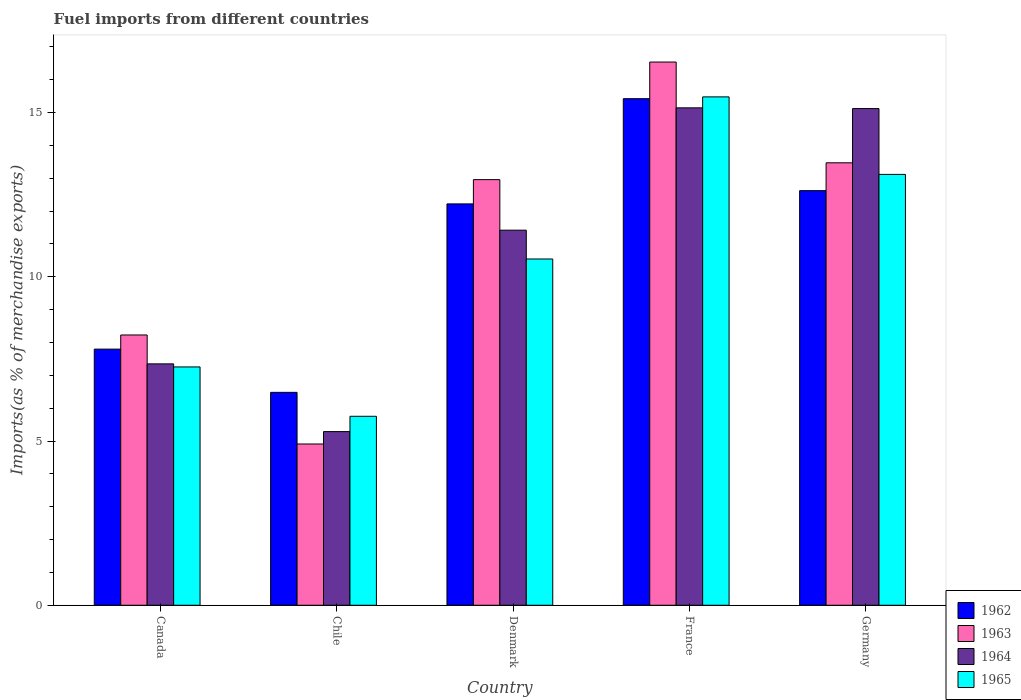Are the number of bars per tick equal to the number of legend labels?
Give a very brief answer. Yes. Are the number of bars on each tick of the X-axis equal?
Provide a succinct answer. Yes. In how many cases, is the number of bars for a given country not equal to the number of legend labels?
Provide a short and direct response. 0. What is the percentage of imports to different countries in 1963 in Canada?
Give a very brief answer. 8.23. Across all countries, what is the maximum percentage of imports to different countries in 1962?
Ensure brevity in your answer.  15.42. Across all countries, what is the minimum percentage of imports to different countries in 1963?
Offer a terse response. 4.91. What is the total percentage of imports to different countries in 1965 in the graph?
Offer a very short reply. 52.14. What is the difference between the percentage of imports to different countries in 1965 in Chile and that in Germany?
Your answer should be very brief. -7.36. What is the difference between the percentage of imports to different countries in 1963 in France and the percentage of imports to different countries in 1965 in Germany?
Your answer should be compact. 3.42. What is the average percentage of imports to different countries in 1965 per country?
Offer a very short reply. 10.43. What is the difference between the percentage of imports to different countries of/in 1963 and percentage of imports to different countries of/in 1965 in Canada?
Keep it short and to the point. 0.97. In how many countries, is the percentage of imports to different countries in 1962 greater than 7 %?
Your answer should be very brief. 4. What is the ratio of the percentage of imports to different countries in 1964 in Chile to that in Germany?
Ensure brevity in your answer.  0.35. Is the difference between the percentage of imports to different countries in 1963 in Chile and Denmark greater than the difference between the percentage of imports to different countries in 1965 in Chile and Denmark?
Make the answer very short. No. What is the difference between the highest and the second highest percentage of imports to different countries in 1963?
Make the answer very short. 3.58. What is the difference between the highest and the lowest percentage of imports to different countries in 1965?
Offer a terse response. 9.72. In how many countries, is the percentage of imports to different countries in 1964 greater than the average percentage of imports to different countries in 1964 taken over all countries?
Keep it short and to the point. 3. What does the 4th bar from the left in France represents?
Your response must be concise. 1965. What does the 4th bar from the right in France represents?
Your answer should be compact. 1962. How many bars are there?
Your answer should be compact. 20. Are all the bars in the graph horizontal?
Ensure brevity in your answer.  No. What is the difference between two consecutive major ticks on the Y-axis?
Make the answer very short. 5. Are the values on the major ticks of Y-axis written in scientific E-notation?
Provide a succinct answer. No. Does the graph contain any zero values?
Provide a short and direct response. No. Where does the legend appear in the graph?
Ensure brevity in your answer.  Bottom right. How many legend labels are there?
Your response must be concise. 4. What is the title of the graph?
Make the answer very short. Fuel imports from different countries. What is the label or title of the Y-axis?
Provide a succinct answer. Imports(as % of merchandise exports). What is the Imports(as % of merchandise exports) of 1962 in Canada?
Your response must be concise. 7.8. What is the Imports(as % of merchandise exports) of 1963 in Canada?
Provide a succinct answer. 8.23. What is the Imports(as % of merchandise exports) of 1964 in Canada?
Your response must be concise. 7.35. What is the Imports(as % of merchandise exports) of 1965 in Canada?
Ensure brevity in your answer.  7.26. What is the Imports(as % of merchandise exports) in 1962 in Chile?
Provide a short and direct response. 6.48. What is the Imports(as % of merchandise exports) in 1963 in Chile?
Give a very brief answer. 4.91. What is the Imports(as % of merchandise exports) of 1964 in Chile?
Your response must be concise. 5.29. What is the Imports(as % of merchandise exports) in 1965 in Chile?
Provide a short and direct response. 5.75. What is the Imports(as % of merchandise exports) of 1962 in Denmark?
Your answer should be very brief. 12.22. What is the Imports(as % of merchandise exports) in 1963 in Denmark?
Your response must be concise. 12.96. What is the Imports(as % of merchandise exports) in 1964 in Denmark?
Your answer should be compact. 11.42. What is the Imports(as % of merchandise exports) in 1965 in Denmark?
Offer a very short reply. 10.54. What is the Imports(as % of merchandise exports) in 1962 in France?
Offer a very short reply. 15.42. What is the Imports(as % of merchandise exports) of 1963 in France?
Offer a very short reply. 16.54. What is the Imports(as % of merchandise exports) of 1964 in France?
Give a very brief answer. 15.14. What is the Imports(as % of merchandise exports) in 1965 in France?
Your answer should be very brief. 15.48. What is the Imports(as % of merchandise exports) in 1962 in Germany?
Give a very brief answer. 12.62. What is the Imports(as % of merchandise exports) in 1963 in Germany?
Ensure brevity in your answer.  13.47. What is the Imports(as % of merchandise exports) of 1964 in Germany?
Your response must be concise. 15.12. What is the Imports(as % of merchandise exports) of 1965 in Germany?
Your response must be concise. 13.12. Across all countries, what is the maximum Imports(as % of merchandise exports) of 1962?
Your answer should be compact. 15.42. Across all countries, what is the maximum Imports(as % of merchandise exports) of 1963?
Make the answer very short. 16.54. Across all countries, what is the maximum Imports(as % of merchandise exports) of 1964?
Keep it short and to the point. 15.14. Across all countries, what is the maximum Imports(as % of merchandise exports) of 1965?
Make the answer very short. 15.48. Across all countries, what is the minimum Imports(as % of merchandise exports) of 1962?
Provide a succinct answer. 6.48. Across all countries, what is the minimum Imports(as % of merchandise exports) in 1963?
Offer a terse response. 4.91. Across all countries, what is the minimum Imports(as % of merchandise exports) of 1964?
Provide a succinct answer. 5.29. Across all countries, what is the minimum Imports(as % of merchandise exports) in 1965?
Keep it short and to the point. 5.75. What is the total Imports(as % of merchandise exports) in 1962 in the graph?
Your answer should be compact. 54.54. What is the total Imports(as % of merchandise exports) of 1963 in the graph?
Your answer should be compact. 56.1. What is the total Imports(as % of merchandise exports) in 1964 in the graph?
Provide a short and direct response. 54.32. What is the total Imports(as % of merchandise exports) of 1965 in the graph?
Ensure brevity in your answer.  52.14. What is the difference between the Imports(as % of merchandise exports) in 1962 in Canada and that in Chile?
Offer a terse response. 1.32. What is the difference between the Imports(as % of merchandise exports) in 1963 in Canada and that in Chile?
Make the answer very short. 3.32. What is the difference between the Imports(as % of merchandise exports) in 1964 in Canada and that in Chile?
Your answer should be very brief. 2.06. What is the difference between the Imports(as % of merchandise exports) in 1965 in Canada and that in Chile?
Make the answer very short. 1.5. What is the difference between the Imports(as % of merchandise exports) in 1962 in Canada and that in Denmark?
Your answer should be compact. -4.42. What is the difference between the Imports(as % of merchandise exports) in 1963 in Canada and that in Denmark?
Your response must be concise. -4.73. What is the difference between the Imports(as % of merchandise exports) in 1964 in Canada and that in Denmark?
Your answer should be very brief. -4.07. What is the difference between the Imports(as % of merchandise exports) in 1965 in Canada and that in Denmark?
Provide a short and direct response. -3.29. What is the difference between the Imports(as % of merchandise exports) of 1962 in Canada and that in France?
Offer a terse response. -7.62. What is the difference between the Imports(as % of merchandise exports) in 1963 in Canada and that in France?
Keep it short and to the point. -8.31. What is the difference between the Imports(as % of merchandise exports) in 1964 in Canada and that in France?
Your answer should be compact. -7.79. What is the difference between the Imports(as % of merchandise exports) in 1965 in Canada and that in France?
Your answer should be compact. -8.22. What is the difference between the Imports(as % of merchandise exports) of 1962 in Canada and that in Germany?
Your answer should be compact. -4.82. What is the difference between the Imports(as % of merchandise exports) in 1963 in Canada and that in Germany?
Your answer should be very brief. -5.24. What is the difference between the Imports(as % of merchandise exports) of 1964 in Canada and that in Germany?
Offer a terse response. -7.77. What is the difference between the Imports(as % of merchandise exports) in 1965 in Canada and that in Germany?
Your response must be concise. -5.86. What is the difference between the Imports(as % of merchandise exports) of 1962 in Chile and that in Denmark?
Provide a short and direct response. -5.74. What is the difference between the Imports(as % of merchandise exports) in 1963 in Chile and that in Denmark?
Make the answer very short. -8.05. What is the difference between the Imports(as % of merchandise exports) of 1964 in Chile and that in Denmark?
Your answer should be very brief. -6.13. What is the difference between the Imports(as % of merchandise exports) in 1965 in Chile and that in Denmark?
Make the answer very short. -4.79. What is the difference between the Imports(as % of merchandise exports) in 1962 in Chile and that in France?
Keep it short and to the point. -8.94. What is the difference between the Imports(as % of merchandise exports) of 1963 in Chile and that in France?
Provide a short and direct response. -11.63. What is the difference between the Imports(as % of merchandise exports) of 1964 in Chile and that in France?
Offer a terse response. -9.86. What is the difference between the Imports(as % of merchandise exports) of 1965 in Chile and that in France?
Provide a succinct answer. -9.72. What is the difference between the Imports(as % of merchandise exports) of 1962 in Chile and that in Germany?
Offer a very short reply. -6.14. What is the difference between the Imports(as % of merchandise exports) in 1963 in Chile and that in Germany?
Make the answer very short. -8.56. What is the difference between the Imports(as % of merchandise exports) in 1964 in Chile and that in Germany?
Ensure brevity in your answer.  -9.83. What is the difference between the Imports(as % of merchandise exports) in 1965 in Chile and that in Germany?
Give a very brief answer. -7.36. What is the difference between the Imports(as % of merchandise exports) in 1962 in Denmark and that in France?
Provide a succinct answer. -3.2. What is the difference between the Imports(as % of merchandise exports) in 1963 in Denmark and that in France?
Your response must be concise. -3.58. What is the difference between the Imports(as % of merchandise exports) in 1964 in Denmark and that in France?
Provide a succinct answer. -3.72. What is the difference between the Imports(as % of merchandise exports) in 1965 in Denmark and that in France?
Your response must be concise. -4.94. What is the difference between the Imports(as % of merchandise exports) of 1962 in Denmark and that in Germany?
Make the answer very short. -0.4. What is the difference between the Imports(as % of merchandise exports) in 1963 in Denmark and that in Germany?
Your response must be concise. -0.51. What is the difference between the Imports(as % of merchandise exports) in 1964 in Denmark and that in Germany?
Keep it short and to the point. -3.7. What is the difference between the Imports(as % of merchandise exports) of 1965 in Denmark and that in Germany?
Provide a short and direct response. -2.58. What is the difference between the Imports(as % of merchandise exports) of 1962 in France and that in Germany?
Your response must be concise. 2.8. What is the difference between the Imports(as % of merchandise exports) in 1963 in France and that in Germany?
Make the answer very short. 3.07. What is the difference between the Imports(as % of merchandise exports) in 1964 in France and that in Germany?
Keep it short and to the point. 0.02. What is the difference between the Imports(as % of merchandise exports) of 1965 in France and that in Germany?
Provide a succinct answer. 2.36. What is the difference between the Imports(as % of merchandise exports) of 1962 in Canada and the Imports(as % of merchandise exports) of 1963 in Chile?
Ensure brevity in your answer.  2.89. What is the difference between the Imports(as % of merchandise exports) of 1962 in Canada and the Imports(as % of merchandise exports) of 1964 in Chile?
Give a very brief answer. 2.51. What is the difference between the Imports(as % of merchandise exports) in 1962 in Canada and the Imports(as % of merchandise exports) in 1965 in Chile?
Offer a terse response. 2.04. What is the difference between the Imports(as % of merchandise exports) in 1963 in Canada and the Imports(as % of merchandise exports) in 1964 in Chile?
Ensure brevity in your answer.  2.94. What is the difference between the Imports(as % of merchandise exports) in 1963 in Canada and the Imports(as % of merchandise exports) in 1965 in Chile?
Ensure brevity in your answer.  2.48. What is the difference between the Imports(as % of merchandise exports) of 1964 in Canada and the Imports(as % of merchandise exports) of 1965 in Chile?
Your answer should be compact. 1.6. What is the difference between the Imports(as % of merchandise exports) of 1962 in Canada and the Imports(as % of merchandise exports) of 1963 in Denmark?
Offer a very short reply. -5.16. What is the difference between the Imports(as % of merchandise exports) of 1962 in Canada and the Imports(as % of merchandise exports) of 1964 in Denmark?
Your response must be concise. -3.62. What is the difference between the Imports(as % of merchandise exports) of 1962 in Canada and the Imports(as % of merchandise exports) of 1965 in Denmark?
Give a very brief answer. -2.74. What is the difference between the Imports(as % of merchandise exports) of 1963 in Canada and the Imports(as % of merchandise exports) of 1964 in Denmark?
Offer a terse response. -3.19. What is the difference between the Imports(as % of merchandise exports) of 1963 in Canada and the Imports(as % of merchandise exports) of 1965 in Denmark?
Make the answer very short. -2.31. What is the difference between the Imports(as % of merchandise exports) in 1964 in Canada and the Imports(as % of merchandise exports) in 1965 in Denmark?
Make the answer very short. -3.19. What is the difference between the Imports(as % of merchandise exports) of 1962 in Canada and the Imports(as % of merchandise exports) of 1963 in France?
Make the answer very short. -8.74. What is the difference between the Imports(as % of merchandise exports) in 1962 in Canada and the Imports(as % of merchandise exports) in 1964 in France?
Make the answer very short. -7.35. What is the difference between the Imports(as % of merchandise exports) of 1962 in Canada and the Imports(as % of merchandise exports) of 1965 in France?
Your answer should be compact. -7.68. What is the difference between the Imports(as % of merchandise exports) of 1963 in Canada and the Imports(as % of merchandise exports) of 1964 in France?
Ensure brevity in your answer.  -6.91. What is the difference between the Imports(as % of merchandise exports) in 1963 in Canada and the Imports(as % of merchandise exports) in 1965 in France?
Provide a succinct answer. -7.25. What is the difference between the Imports(as % of merchandise exports) of 1964 in Canada and the Imports(as % of merchandise exports) of 1965 in France?
Your answer should be compact. -8.13. What is the difference between the Imports(as % of merchandise exports) in 1962 in Canada and the Imports(as % of merchandise exports) in 1963 in Germany?
Keep it short and to the point. -5.67. What is the difference between the Imports(as % of merchandise exports) of 1962 in Canada and the Imports(as % of merchandise exports) of 1964 in Germany?
Your response must be concise. -7.32. What is the difference between the Imports(as % of merchandise exports) in 1962 in Canada and the Imports(as % of merchandise exports) in 1965 in Germany?
Ensure brevity in your answer.  -5.32. What is the difference between the Imports(as % of merchandise exports) of 1963 in Canada and the Imports(as % of merchandise exports) of 1964 in Germany?
Provide a succinct answer. -6.89. What is the difference between the Imports(as % of merchandise exports) of 1963 in Canada and the Imports(as % of merchandise exports) of 1965 in Germany?
Keep it short and to the point. -4.89. What is the difference between the Imports(as % of merchandise exports) of 1964 in Canada and the Imports(as % of merchandise exports) of 1965 in Germany?
Offer a terse response. -5.77. What is the difference between the Imports(as % of merchandise exports) in 1962 in Chile and the Imports(as % of merchandise exports) in 1963 in Denmark?
Provide a succinct answer. -6.48. What is the difference between the Imports(as % of merchandise exports) in 1962 in Chile and the Imports(as % of merchandise exports) in 1964 in Denmark?
Provide a succinct answer. -4.94. What is the difference between the Imports(as % of merchandise exports) of 1962 in Chile and the Imports(as % of merchandise exports) of 1965 in Denmark?
Your response must be concise. -4.06. What is the difference between the Imports(as % of merchandise exports) in 1963 in Chile and the Imports(as % of merchandise exports) in 1964 in Denmark?
Keep it short and to the point. -6.51. What is the difference between the Imports(as % of merchandise exports) of 1963 in Chile and the Imports(as % of merchandise exports) of 1965 in Denmark?
Make the answer very short. -5.63. What is the difference between the Imports(as % of merchandise exports) in 1964 in Chile and the Imports(as % of merchandise exports) in 1965 in Denmark?
Your answer should be very brief. -5.25. What is the difference between the Imports(as % of merchandise exports) of 1962 in Chile and the Imports(as % of merchandise exports) of 1963 in France?
Make the answer very short. -10.06. What is the difference between the Imports(as % of merchandise exports) of 1962 in Chile and the Imports(as % of merchandise exports) of 1964 in France?
Provide a succinct answer. -8.66. What is the difference between the Imports(as % of merchandise exports) in 1962 in Chile and the Imports(as % of merchandise exports) in 1965 in France?
Make the answer very short. -9. What is the difference between the Imports(as % of merchandise exports) in 1963 in Chile and the Imports(as % of merchandise exports) in 1964 in France?
Keep it short and to the point. -10.23. What is the difference between the Imports(as % of merchandise exports) in 1963 in Chile and the Imports(as % of merchandise exports) in 1965 in France?
Provide a short and direct response. -10.57. What is the difference between the Imports(as % of merchandise exports) of 1964 in Chile and the Imports(as % of merchandise exports) of 1965 in France?
Offer a terse response. -10.19. What is the difference between the Imports(as % of merchandise exports) in 1962 in Chile and the Imports(as % of merchandise exports) in 1963 in Germany?
Your answer should be very brief. -6.99. What is the difference between the Imports(as % of merchandise exports) of 1962 in Chile and the Imports(as % of merchandise exports) of 1964 in Germany?
Your response must be concise. -8.64. What is the difference between the Imports(as % of merchandise exports) of 1962 in Chile and the Imports(as % of merchandise exports) of 1965 in Germany?
Make the answer very short. -6.64. What is the difference between the Imports(as % of merchandise exports) of 1963 in Chile and the Imports(as % of merchandise exports) of 1964 in Germany?
Ensure brevity in your answer.  -10.21. What is the difference between the Imports(as % of merchandise exports) in 1963 in Chile and the Imports(as % of merchandise exports) in 1965 in Germany?
Your response must be concise. -8.21. What is the difference between the Imports(as % of merchandise exports) in 1964 in Chile and the Imports(as % of merchandise exports) in 1965 in Germany?
Provide a succinct answer. -7.83. What is the difference between the Imports(as % of merchandise exports) of 1962 in Denmark and the Imports(as % of merchandise exports) of 1963 in France?
Provide a succinct answer. -4.32. What is the difference between the Imports(as % of merchandise exports) in 1962 in Denmark and the Imports(as % of merchandise exports) in 1964 in France?
Your response must be concise. -2.92. What is the difference between the Imports(as % of merchandise exports) of 1962 in Denmark and the Imports(as % of merchandise exports) of 1965 in France?
Make the answer very short. -3.26. What is the difference between the Imports(as % of merchandise exports) of 1963 in Denmark and the Imports(as % of merchandise exports) of 1964 in France?
Offer a very short reply. -2.19. What is the difference between the Imports(as % of merchandise exports) in 1963 in Denmark and the Imports(as % of merchandise exports) in 1965 in France?
Give a very brief answer. -2.52. What is the difference between the Imports(as % of merchandise exports) of 1964 in Denmark and the Imports(as % of merchandise exports) of 1965 in France?
Your answer should be very brief. -4.06. What is the difference between the Imports(as % of merchandise exports) of 1962 in Denmark and the Imports(as % of merchandise exports) of 1963 in Germany?
Give a very brief answer. -1.25. What is the difference between the Imports(as % of merchandise exports) in 1962 in Denmark and the Imports(as % of merchandise exports) in 1964 in Germany?
Ensure brevity in your answer.  -2.9. What is the difference between the Imports(as % of merchandise exports) in 1962 in Denmark and the Imports(as % of merchandise exports) in 1965 in Germany?
Make the answer very short. -0.9. What is the difference between the Imports(as % of merchandise exports) of 1963 in Denmark and the Imports(as % of merchandise exports) of 1964 in Germany?
Offer a very short reply. -2.16. What is the difference between the Imports(as % of merchandise exports) of 1963 in Denmark and the Imports(as % of merchandise exports) of 1965 in Germany?
Offer a terse response. -0.16. What is the difference between the Imports(as % of merchandise exports) of 1964 in Denmark and the Imports(as % of merchandise exports) of 1965 in Germany?
Your response must be concise. -1.7. What is the difference between the Imports(as % of merchandise exports) in 1962 in France and the Imports(as % of merchandise exports) in 1963 in Germany?
Your response must be concise. 1.95. What is the difference between the Imports(as % of merchandise exports) in 1962 in France and the Imports(as % of merchandise exports) in 1964 in Germany?
Give a very brief answer. 0.3. What is the difference between the Imports(as % of merchandise exports) of 1962 in France and the Imports(as % of merchandise exports) of 1965 in Germany?
Your response must be concise. 2.31. What is the difference between the Imports(as % of merchandise exports) in 1963 in France and the Imports(as % of merchandise exports) in 1964 in Germany?
Offer a very short reply. 1.42. What is the difference between the Imports(as % of merchandise exports) in 1963 in France and the Imports(as % of merchandise exports) in 1965 in Germany?
Your answer should be compact. 3.42. What is the difference between the Imports(as % of merchandise exports) in 1964 in France and the Imports(as % of merchandise exports) in 1965 in Germany?
Ensure brevity in your answer.  2.03. What is the average Imports(as % of merchandise exports) in 1962 per country?
Your answer should be very brief. 10.91. What is the average Imports(as % of merchandise exports) of 1963 per country?
Provide a succinct answer. 11.22. What is the average Imports(as % of merchandise exports) of 1964 per country?
Offer a terse response. 10.86. What is the average Imports(as % of merchandise exports) of 1965 per country?
Your answer should be compact. 10.43. What is the difference between the Imports(as % of merchandise exports) in 1962 and Imports(as % of merchandise exports) in 1963 in Canada?
Offer a very short reply. -0.43. What is the difference between the Imports(as % of merchandise exports) in 1962 and Imports(as % of merchandise exports) in 1964 in Canada?
Provide a short and direct response. 0.45. What is the difference between the Imports(as % of merchandise exports) of 1962 and Imports(as % of merchandise exports) of 1965 in Canada?
Make the answer very short. 0.54. What is the difference between the Imports(as % of merchandise exports) in 1963 and Imports(as % of merchandise exports) in 1964 in Canada?
Your answer should be very brief. 0.88. What is the difference between the Imports(as % of merchandise exports) in 1963 and Imports(as % of merchandise exports) in 1965 in Canada?
Give a very brief answer. 0.97. What is the difference between the Imports(as % of merchandise exports) of 1964 and Imports(as % of merchandise exports) of 1965 in Canada?
Ensure brevity in your answer.  0.09. What is the difference between the Imports(as % of merchandise exports) in 1962 and Imports(as % of merchandise exports) in 1963 in Chile?
Provide a short and direct response. 1.57. What is the difference between the Imports(as % of merchandise exports) in 1962 and Imports(as % of merchandise exports) in 1964 in Chile?
Offer a terse response. 1.19. What is the difference between the Imports(as % of merchandise exports) in 1962 and Imports(as % of merchandise exports) in 1965 in Chile?
Make the answer very short. 0.73. What is the difference between the Imports(as % of merchandise exports) in 1963 and Imports(as % of merchandise exports) in 1964 in Chile?
Keep it short and to the point. -0.38. What is the difference between the Imports(as % of merchandise exports) of 1963 and Imports(as % of merchandise exports) of 1965 in Chile?
Provide a succinct answer. -0.84. What is the difference between the Imports(as % of merchandise exports) in 1964 and Imports(as % of merchandise exports) in 1965 in Chile?
Offer a very short reply. -0.47. What is the difference between the Imports(as % of merchandise exports) in 1962 and Imports(as % of merchandise exports) in 1963 in Denmark?
Offer a terse response. -0.74. What is the difference between the Imports(as % of merchandise exports) in 1962 and Imports(as % of merchandise exports) in 1964 in Denmark?
Give a very brief answer. 0.8. What is the difference between the Imports(as % of merchandise exports) of 1962 and Imports(as % of merchandise exports) of 1965 in Denmark?
Your response must be concise. 1.68. What is the difference between the Imports(as % of merchandise exports) of 1963 and Imports(as % of merchandise exports) of 1964 in Denmark?
Make the answer very short. 1.54. What is the difference between the Imports(as % of merchandise exports) of 1963 and Imports(as % of merchandise exports) of 1965 in Denmark?
Keep it short and to the point. 2.42. What is the difference between the Imports(as % of merchandise exports) in 1964 and Imports(as % of merchandise exports) in 1965 in Denmark?
Provide a succinct answer. 0.88. What is the difference between the Imports(as % of merchandise exports) in 1962 and Imports(as % of merchandise exports) in 1963 in France?
Your answer should be very brief. -1.12. What is the difference between the Imports(as % of merchandise exports) in 1962 and Imports(as % of merchandise exports) in 1964 in France?
Offer a terse response. 0.28. What is the difference between the Imports(as % of merchandise exports) of 1962 and Imports(as % of merchandise exports) of 1965 in France?
Offer a very short reply. -0.05. What is the difference between the Imports(as % of merchandise exports) in 1963 and Imports(as % of merchandise exports) in 1964 in France?
Keep it short and to the point. 1.39. What is the difference between the Imports(as % of merchandise exports) of 1963 and Imports(as % of merchandise exports) of 1965 in France?
Your response must be concise. 1.06. What is the difference between the Imports(as % of merchandise exports) of 1964 and Imports(as % of merchandise exports) of 1965 in France?
Ensure brevity in your answer.  -0.33. What is the difference between the Imports(as % of merchandise exports) of 1962 and Imports(as % of merchandise exports) of 1963 in Germany?
Offer a terse response. -0.85. What is the difference between the Imports(as % of merchandise exports) in 1962 and Imports(as % of merchandise exports) in 1964 in Germany?
Your answer should be very brief. -2.5. What is the difference between the Imports(as % of merchandise exports) of 1962 and Imports(as % of merchandise exports) of 1965 in Germany?
Provide a short and direct response. -0.49. What is the difference between the Imports(as % of merchandise exports) in 1963 and Imports(as % of merchandise exports) in 1964 in Germany?
Offer a terse response. -1.65. What is the difference between the Imports(as % of merchandise exports) in 1963 and Imports(as % of merchandise exports) in 1965 in Germany?
Your answer should be compact. 0.35. What is the difference between the Imports(as % of merchandise exports) in 1964 and Imports(as % of merchandise exports) in 1965 in Germany?
Give a very brief answer. 2. What is the ratio of the Imports(as % of merchandise exports) in 1962 in Canada to that in Chile?
Offer a very short reply. 1.2. What is the ratio of the Imports(as % of merchandise exports) in 1963 in Canada to that in Chile?
Your response must be concise. 1.68. What is the ratio of the Imports(as % of merchandise exports) in 1964 in Canada to that in Chile?
Offer a very short reply. 1.39. What is the ratio of the Imports(as % of merchandise exports) of 1965 in Canada to that in Chile?
Give a very brief answer. 1.26. What is the ratio of the Imports(as % of merchandise exports) of 1962 in Canada to that in Denmark?
Offer a terse response. 0.64. What is the ratio of the Imports(as % of merchandise exports) in 1963 in Canada to that in Denmark?
Offer a terse response. 0.64. What is the ratio of the Imports(as % of merchandise exports) in 1964 in Canada to that in Denmark?
Offer a terse response. 0.64. What is the ratio of the Imports(as % of merchandise exports) of 1965 in Canada to that in Denmark?
Your answer should be very brief. 0.69. What is the ratio of the Imports(as % of merchandise exports) in 1962 in Canada to that in France?
Make the answer very short. 0.51. What is the ratio of the Imports(as % of merchandise exports) of 1963 in Canada to that in France?
Your answer should be very brief. 0.5. What is the ratio of the Imports(as % of merchandise exports) in 1964 in Canada to that in France?
Your answer should be compact. 0.49. What is the ratio of the Imports(as % of merchandise exports) of 1965 in Canada to that in France?
Your answer should be compact. 0.47. What is the ratio of the Imports(as % of merchandise exports) in 1962 in Canada to that in Germany?
Your answer should be compact. 0.62. What is the ratio of the Imports(as % of merchandise exports) of 1963 in Canada to that in Germany?
Your answer should be very brief. 0.61. What is the ratio of the Imports(as % of merchandise exports) in 1964 in Canada to that in Germany?
Provide a short and direct response. 0.49. What is the ratio of the Imports(as % of merchandise exports) in 1965 in Canada to that in Germany?
Make the answer very short. 0.55. What is the ratio of the Imports(as % of merchandise exports) of 1962 in Chile to that in Denmark?
Your answer should be very brief. 0.53. What is the ratio of the Imports(as % of merchandise exports) in 1963 in Chile to that in Denmark?
Keep it short and to the point. 0.38. What is the ratio of the Imports(as % of merchandise exports) in 1964 in Chile to that in Denmark?
Your response must be concise. 0.46. What is the ratio of the Imports(as % of merchandise exports) in 1965 in Chile to that in Denmark?
Provide a short and direct response. 0.55. What is the ratio of the Imports(as % of merchandise exports) of 1962 in Chile to that in France?
Ensure brevity in your answer.  0.42. What is the ratio of the Imports(as % of merchandise exports) in 1963 in Chile to that in France?
Give a very brief answer. 0.3. What is the ratio of the Imports(as % of merchandise exports) in 1964 in Chile to that in France?
Keep it short and to the point. 0.35. What is the ratio of the Imports(as % of merchandise exports) in 1965 in Chile to that in France?
Provide a succinct answer. 0.37. What is the ratio of the Imports(as % of merchandise exports) of 1962 in Chile to that in Germany?
Provide a short and direct response. 0.51. What is the ratio of the Imports(as % of merchandise exports) in 1963 in Chile to that in Germany?
Provide a short and direct response. 0.36. What is the ratio of the Imports(as % of merchandise exports) in 1964 in Chile to that in Germany?
Offer a terse response. 0.35. What is the ratio of the Imports(as % of merchandise exports) in 1965 in Chile to that in Germany?
Ensure brevity in your answer.  0.44. What is the ratio of the Imports(as % of merchandise exports) in 1962 in Denmark to that in France?
Your response must be concise. 0.79. What is the ratio of the Imports(as % of merchandise exports) in 1963 in Denmark to that in France?
Your answer should be very brief. 0.78. What is the ratio of the Imports(as % of merchandise exports) of 1964 in Denmark to that in France?
Provide a succinct answer. 0.75. What is the ratio of the Imports(as % of merchandise exports) in 1965 in Denmark to that in France?
Give a very brief answer. 0.68. What is the ratio of the Imports(as % of merchandise exports) of 1963 in Denmark to that in Germany?
Make the answer very short. 0.96. What is the ratio of the Imports(as % of merchandise exports) of 1964 in Denmark to that in Germany?
Provide a short and direct response. 0.76. What is the ratio of the Imports(as % of merchandise exports) of 1965 in Denmark to that in Germany?
Keep it short and to the point. 0.8. What is the ratio of the Imports(as % of merchandise exports) of 1962 in France to that in Germany?
Make the answer very short. 1.22. What is the ratio of the Imports(as % of merchandise exports) of 1963 in France to that in Germany?
Give a very brief answer. 1.23. What is the ratio of the Imports(as % of merchandise exports) of 1964 in France to that in Germany?
Your answer should be very brief. 1. What is the ratio of the Imports(as % of merchandise exports) in 1965 in France to that in Germany?
Ensure brevity in your answer.  1.18. What is the difference between the highest and the second highest Imports(as % of merchandise exports) in 1962?
Give a very brief answer. 2.8. What is the difference between the highest and the second highest Imports(as % of merchandise exports) of 1963?
Make the answer very short. 3.07. What is the difference between the highest and the second highest Imports(as % of merchandise exports) in 1964?
Provide a succinct answer. 0.02. What is the difference between the highest and the second highest Imports(as % of merchandise exports) of 1965?
Offer a very short reply. 2.36. What is the difference between the highest and the lowest Imports(as % of merchandise exports) in 1962?
Your response must be concise. 8.94. What is the difference between the highest and the lowest Imports(as % of merchandise exports) in 1963?
Provide a short and direct response. 11.63. What is the difference between the highest and the lowest Imports(as % of merchandise exports) in 1964?
Keep it short and to the point. 9.86. What is the difference between the highest and the lowest Imports(as % of merchandise exports) of 1965?
Ensure brevity in your answer.  9.72. 